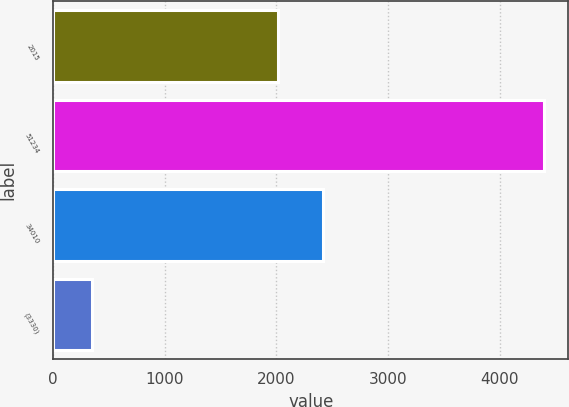Convert chart to OTSL. <chart><loc_0><loc_0><loc_500><loc_500><bar_chart><fcel>2015<fcel>51234<fcel>34010<fcel>(3330)<nl><fcel>2013<fcel>4395.1<fcel>2417.72<fcel>347.9<nl></chart> 